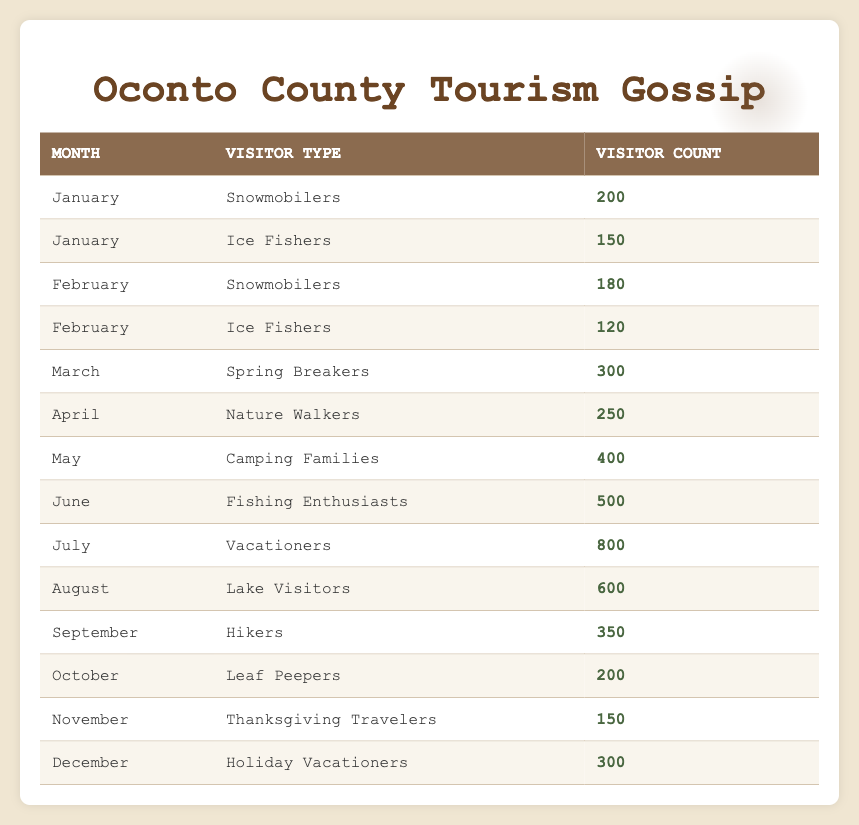What was the visitor count for Snowmobilers in January? In the table, I can find the row for January under Snowmobilers. The Visitor Count listed there is 200.
Answer: 200 Which month had the highest number of Camping Families? The only month listed with Camping Families is May, and the Visitor Count for that month is 400, so that's the highest count for this type.
Answer: 400 Did Leaf Peepers visit in December? The table does not mention Leaf Peepers in December; this visitor type is only listed for October. Therefore, the answer is no.
Answer: No What is the total number of visitors for Fishing Enthusiasts and Ice Fishers combined? For Fishing Enthusiasts in June, the Visitor Count is 500. For Ice Fishers in January, the Visitor Count is 150. Adding these together gives 500 + 150 = 650.
Answer: 650 How many more Vacationers visited Oconto County in July compared to Ice Fishers in February? The Visitor Count for Vacationers in July is 800, while for Ice Fishers in February, it is 120. The difference is 800 - 120 = 680.
Answer: 680 What is the average number of visitors for each month from January to March? The Visitor Counts for January are 200 and 150, for February are 180 and 120, and for March is 300. The total is 200 + 150 + 180 + 120 + 300 = 950, and there are 5 data points, so the average is 950 / 5 = 190.
Answer: 190 Which visitor type saw a decrease from January to February? Snowmobilers went from 200 visitors in January to 180 in February, while Ice Fishers also decreased from 150 to 120. I check each row to see the counts.
Answer: Snowmobilers and Ice Fishers What is the total count of visitors in the summer months (June, July, and August)? First, identify the visitor counts for the summer months: June has 500 (Fishing Enthusiasts), July has 800 (Vacationers), and August has 600 (Lake Visitors). Adding these together gives 500 + 800 + 600 = 1900.
Answer: 1900 In what month do Thanksgiving Travelers visit? The table indicates that Thanksgiving Travelers are listed under November.
Answer: November 